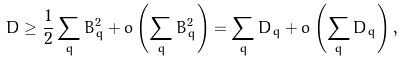Convert formula to latex. <formula><loc_0><loc_0><loc_500><loc_500>D \geq \frac { 1 } { 2 } \sum _ { q } B ^ { 2 } _ { q } + o \left ( \sum _ { q } B _ { q } ^ { 2 } \right ) = \sum _ { q } D _ { q } + o \left ( \sum _ { q } D _ { q } \right ) ,</formula> 